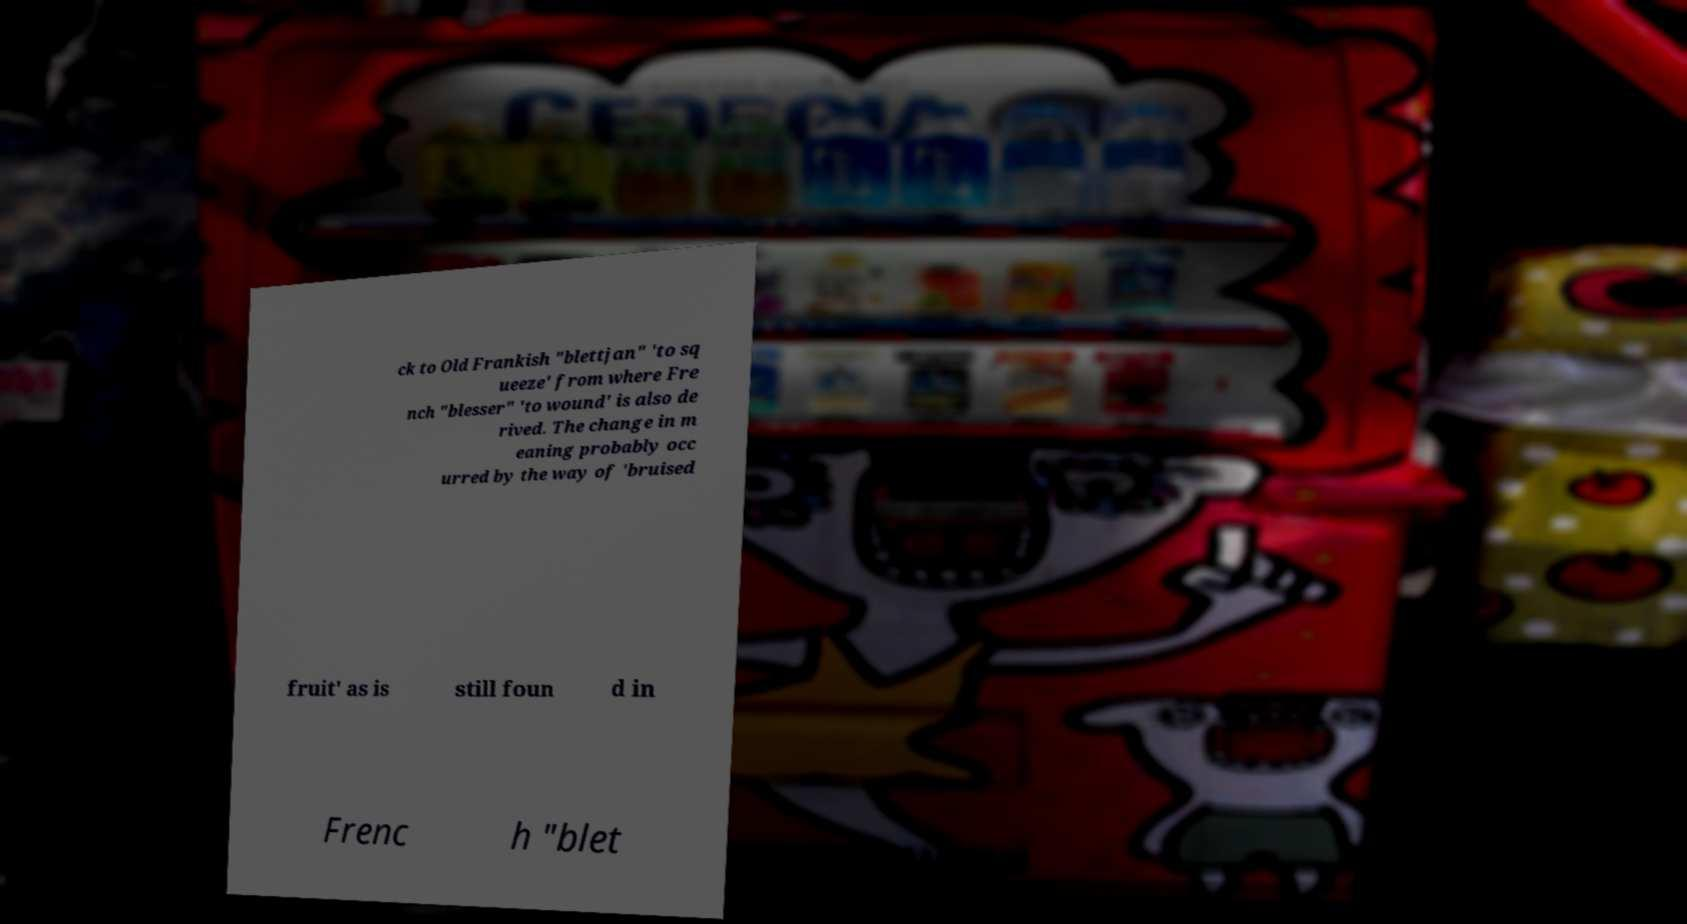Can you read and provide the text displayed in the image?This photo seems to have some interesting text. Can you extract and type it out for me? ck to Old Frankish "blettjan" 'to sq ueeze' from where Fre nch "blesser" 'to wound' is also de rived. The change in m eaning probably occ urred by the way of 'bruised fruit' as is still foun d in Frenc h "blet 